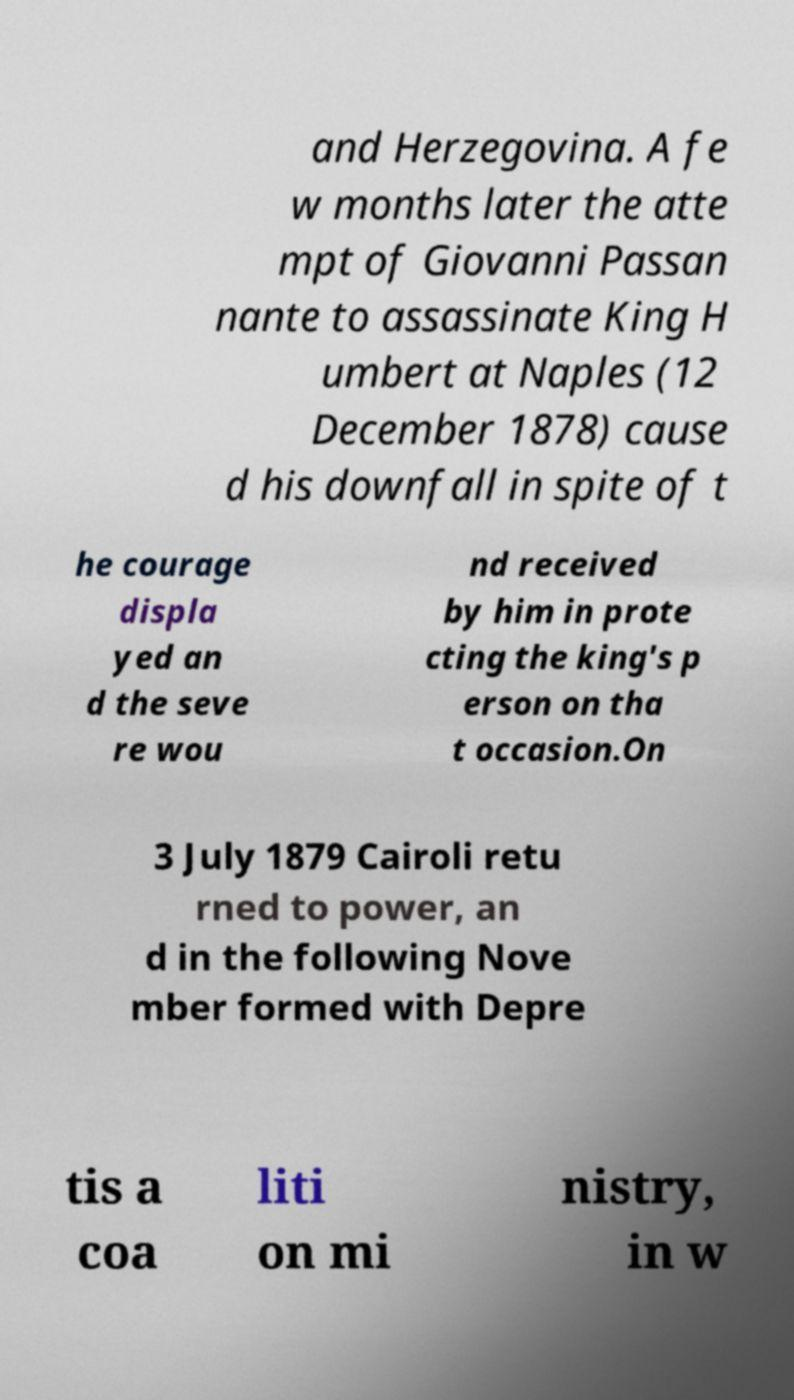There's text embedded in this image that I need extracted. Can you transcribe it verbatim? and Herzegovina. A fe w months later the atte mpt of Giovanni Passan nante to assassinate King H umbert at Naples (12 December 1878) cause d his downfall in spite of t he courage displa yed an d the seve re wou nd received by him in prote cting the king's p erson on tha t occasion.On 3 July 1879 Cairoli retu rned to power, an d in the following Nove mber formed with Depre tis a coa liti on mi nistry, in w 